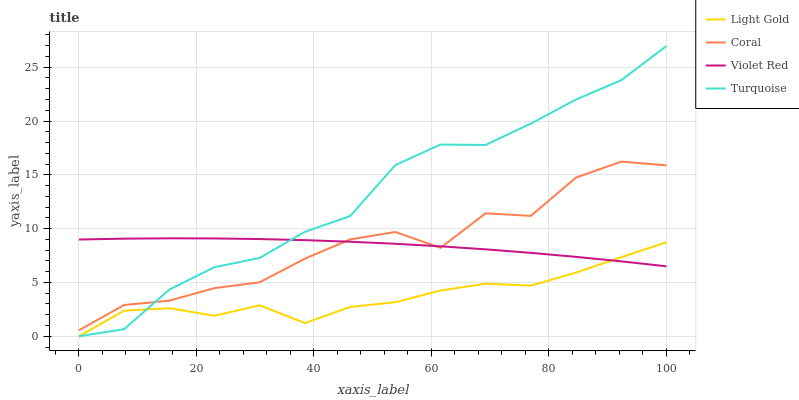Does Light Gold have the minimum area under the curve?
Answer yes or no. Yes. Does Turquoise have the maximum area under the curve?
Answer yes or no. Yes. Does Turquoise have the minimum area under the curve?
Answer yes or no. No. Does Light Gold have the maximum area under the curve?
Answer yes or no. No. Is Violet Red the smoothest?
Answer yes or no. Yes. Is Coral the roughest?
Answer yes or no. Yes. Is Turquoise the smoothest?
Answer yes or no. No. Is Turquoise the roughest?
Answer yes or no. No. Does Violet Red have the lowest value?
Answer yes or no. No. Does Turquoise have the highest value?
Answer yes or no. Yes. Does Light Gold have the highest value?
Answer yes or no. No. Is Light Gold less than Coral?
Answer yes or no. Yes. Is Coral greater than Light Gold?
Answer yes or no. Yes. Does Violet Red intersect Turquoise?
Answer yes or no. Yes. Is Violet Red less than Turquoise?
Answer yes or no. No. Is Violet Red greater than Turquoise?
Answer yes or no. No. Does Light Gold intersect Coral?
Answer yes or no. No. 